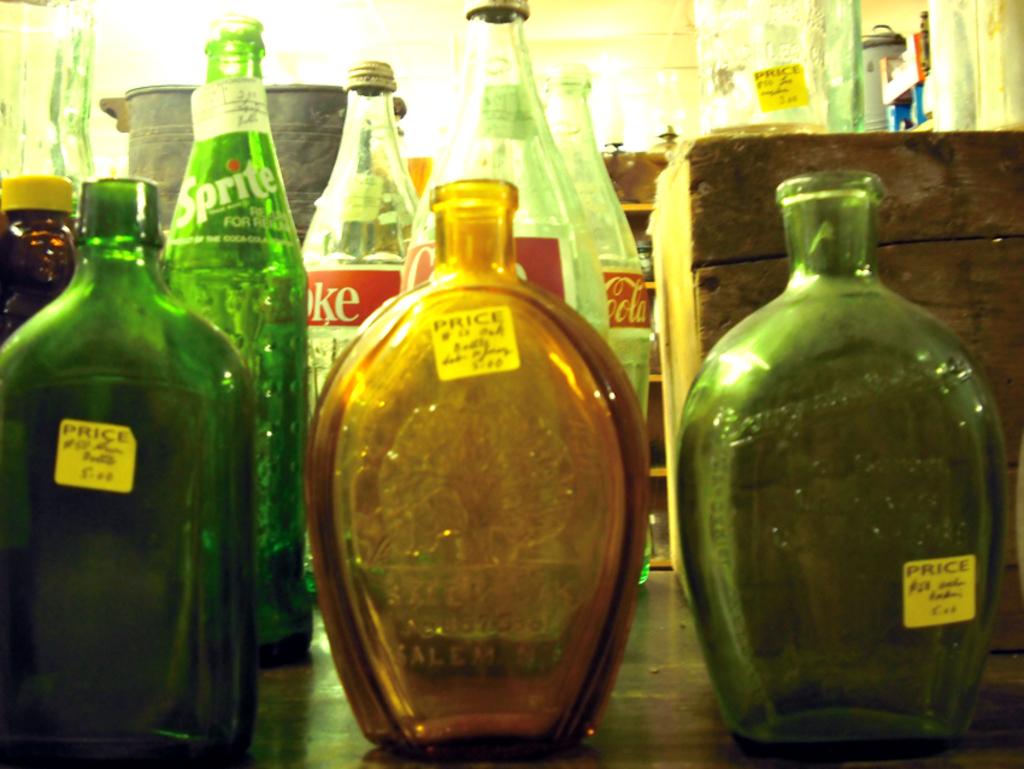What label is on the green bottle?
Provide a succinct answer. Sprite. What soft drink is behind the left bottle?
Ensure brevity in your answer.  Sprite. 